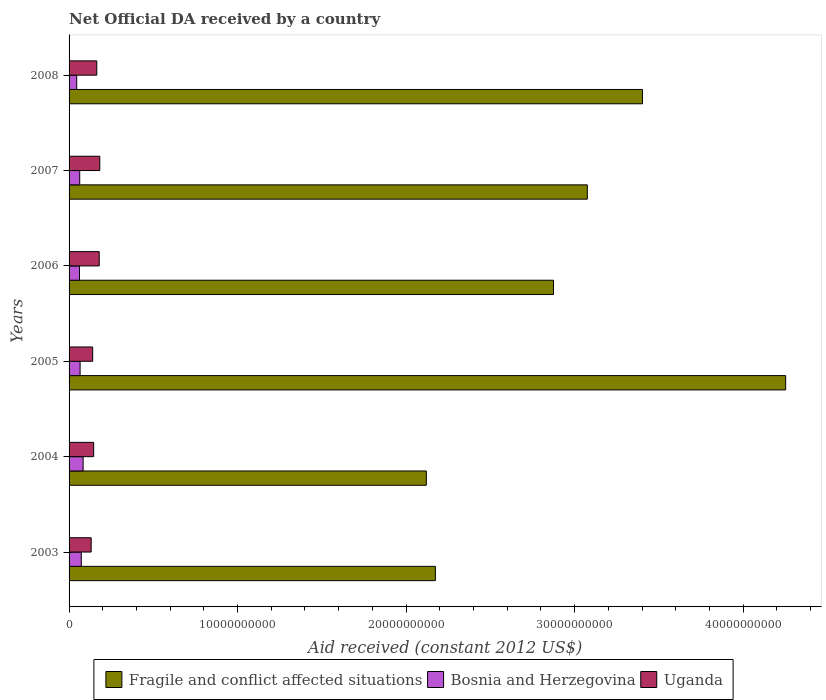How many groups of bars are there?
Offer a very short reply. 6. How many bars are there on the 2nd tick from the top?
Your answer should be compact. 3. How many bars are there on the 1st tick from the bottom?
Ensure brevity in your answer.  3. What is the net official development assistance aid received in Bosnia and Herzegovina in 2003?
Your answer should be very brief. 7.27e+08. Across all years, what is the maximum net official development assistance aid received in Bosnia and Herzegovina?
Your response must be concise. 8.34e+08. Across all years, what is the minimum net official development assistance aid received in Uganda?
Provide a succinct answer. 1.31e+09. In which year was the net official development assistance aid received in Bosnia and Herzegovina maximum?
Your answer should be very brief. 2004. What is the total net official development assistance aid received in Bosnia and Herzegovina in the graph?
Make the answer very short. 3.92e+09. What is the difference between the net official development assistance aid received in Bosnia and Herzegovina in 2003 and that in 2006?
Make the answer very short. 1.08e+08. What is the difference between the net official development assistance aid received in Fragile and conflict affected situations in 2004 and the net official development assistance aid received in Uganda in 2003?
Ensure brevity in your answer.  1.99e+1. What is the average net official development assistance aid received in Fragile and conflict affected situations per year?
Your answer should be very brief. 2.98e+1. In the year 2007, what is the difference between the net official development assistance aid received in Fragile and conflict affected situations and net official development assistance aid received in Bosnia and Herzegovina?
Offer a terse response. 3.01e+1. In how many years, is the net official development assistance aid received in Fragile and conflict affected situations greater than 20000000000 US$?
Ensure brevity in your answer.  6. What is the ratio of the net official development assistance aid received in Bosnia and Herzegovina in 2005 to that in 2008?
Provide a succinct answer. 1.44. Is the difference between the net official development assistance aid received in Fragile and conflict affected situations in 2003 and 2005 greater than the difference between the net official development assistance aid received in Bosnia and Herzegovina in 2003 and 2005?
Your response must be concise. No. What is the difference between the highest and the second highest net official development assistance aid received in Bosnia and Herzegovina?
Provide a succinct answer. 1.07e+08. What is the difference between the highest and the lowest net official development assistance aid received in Uganda?
Offer a terse response. 5.11e+08. What does the 2nd bar from the top in 2007 represents?
Offer a terse response. Bosnia and Herzegovina. What does the 1st bar from the bottom in 2005 represents?
Keep it short and to the point. Fragile and conflict affected situations. Is it the case that in every year, the sum of the net official development assistance aid received in Uganda and net official development assistance aid received in Bosnia and Herzegovina is greater than the net official development assistance aid received in Fragile and conflict affected situations?
Provide a succinct answer. No. Are the values on the major ticks of X-axis written in scientific E-notation?
Give a very brief answer. No. Does the graph contain any zero values?
Give a very brief answer. No. Where does the legend appear in the graph?
Make the answer very short. Bottom center. How are the legend labels stacked?
Offer a very short reply. Horizontal. What is the title of the graph?
Keep it short and to the point. Net Official DA received by a country. What is the label or title of the X-axis?
Keep it short and to the point. Aid received (constant 2012 US$). What is the Aid received (constant 2012 US$) of Fragile and conflict affected situations in 2003?
Ensure brevity in your answer.  2.17e+1. What is the Aid received (constant 2012 US$) in Bosnia and Herzegovina in 2003?
Your answer should be compact. 7.27e+08. What is the Aid received (constant 2012 US$) of Uganda in 2003?
Give a very brief answer. 1.31e+09. What is the Aid received (constant 2012 US$) in Fragile and conflict affected situations in 2004?
Ensure brevity in your answer.  2.12e+1. What is the Aid received (constant 2012 US$) of Bosnia and Herzegovina in 2004?
Ensure brevity in your answer.  8.34e+08. What is the Aid received (constant 2012 US$) of Uganda in 2004?
Offer a terse response. 1.46e+09. What is the Aid received (constant 2012 US$) of Fragile and conflict affected situations in 2005?
Make the answer very short. 4.25e+1. What is the Aid received (constant 2012 US$) in Bosnia and Herzegovina in 2005?
Your answer should be compact. 6.54e+08. What is the Aid received (constant 2012 US$) of Uganda in 2005?
Your answer should be compact. 1.40e+09. What is the Aid received (constant 2012 US$) in Fragile and conflict affected situations in 2006?
Provide a succinct answer. 2.87e+1. What is the Aid received (constant 2012 US$) of Bosnia and Herzegovina in 2006?
Your answer should be very brief. 6.19e+08. What is the Aid received (constant 2012 US$) in Uganda in 2006?
Offer a terse response. 1.79e+09. What is the Aid received (constant 2012 US$) in Fragile and conflict affected situations in 2007?
Your answer should be very brief. 3.08e+1. What is the Aid received (constant 2012 US$) in Bosnia and Herzegovina in 2007?
Your answer should be compact. 6.32e+08. What is the Aid received (constant 2012 US$) of Uganda in 2007?
Keep it short and to the point. 1.82e+09. What is the Aid received (constant 2012 US$) of Fragile and conflict affected situations in 2008?
Ensure brevity in your answer.  3.40e+1. What is the Aid received (constant 2012 US$) in Bosnia and Herzegovina in 2008?
Your response must be concise. 4.54e+08. What is the Aid received (constant 2012 US$) in Uganda in 2008?
Your response must be concise. 1.64e+09. Across all years, what is the maximum Aid received (constant 2012 US$) of Fragile and conflict affected situations?
Give a very brief answer. 4.25e+1. Across all years, what is the maximum Aid received (constant 2012 US$) in Bosnia and Herzegovina?
Keep it short and to the point. 8.34e+08. Across all years, what is the maximum Aid received (constant 2012 US$) in Uganda?
Make the answer very short. 1.82e+09. Across all years, what is the minimum Aid received (constant 2012 US$) in Fragile and conflict affected situations?
Provide a succinct answer. 2.12e+1. Across all years, what is the minimum Aid received (constant 2012 US$) of Bosnia and Herzegovina?
Make the answer very short. 4.54e+08. Across all years, what is the minimum Aid received (constant 2012 US$) of Uganda?
Keep it short and to the point. 1.31e+09. What is the total Aid received (constant 2012 US$) of Fragile and conflict affected situations in the graph?
Offer a very short reply. 1.79e+11. What is the total Aid received (constant 2012 US$) of Bosnia and Herzegovina in the graph?
Your answer should be very brief. 3.92e+09. What is the total Aid received (constant 2012 US$) of Uganda in the graph?
Make the answer very short. 9.43e+09. What is the difference between the Aid received (constant 2012 US$) in Fragile and conflict affected situations in 2003 and that in 2004?
Make the answer very short. 5.38e+08. What is the difference between the Aid received (constant 2012 US$) in Bosnia and Herzegovina in 2003 and that in 2004?
Offer a terse response. -1.07e+08. What is the difference between the Aid received (constant 2012 US$) in Uganda in 2003 and that in 2004?
Your answer should be compact. -1.49e+08. What is the difference between the Aid received (constant 2012 US$) of Fragile and conflict affected situations in 2003 and that in 2005?
Ensure brevity in your answer.  -2.08e+1. What is the difference between the Aid received (constant 2012 US$) of Bosnia and Herzegovina in 2003 and that in 2005?
Offer a very short reply. 7.26e+07. What is the difference between the Aid received (constant 2012 US$) in Uganda in 2003 and that in 2005?
Your response must be concise. -8.92e+07. What is the difference between the Aid received (constant 2012 US$) of Fragile and conflict affected situations in 2003 and that in 2006?
Ensure brevity in your answer.  -7.01e+09. What is the difference between the Aid received (constant 2012 US$) of Bosnia and Herzegovina in 2003 and that in 2006?
Your response must be concise. 1.08e+08. What is the difference between the Aid received (constant 2012 US$) in Uganda in 2003 and that in 2006?
Your answer should be compact. -4.77e+08. What is the difference between the Aid received (constant 2012 US$) of Fragile and conflict affected situations in 2003 and that in 2007?
Offer a very short reply. -9.02e+09. What is the difference between the Aid received (constant 2012 US$) in Bosnia and Herzegovina in 2003 and that in 2007?
Make the answer very short. 9.45e+07. What is the difference between the Aid received (constant 2012 US$) of Uganda in 2003 and that in 2007?
Your answer should be very brief. -5.11e+08. What is the difference between the Aid received (constant 2012 US$) of Fragile and conflict affected situations in 2003 and that in 2008?
Keep it short and to the point. -1.23e+1. What is the difference between the Aid received (constant 2012 US$) of Bosnia and Herzegovina in 2003 and that in 2008?
Keep it short and to the point. 2.73e+08. What is the difference between the Aid received (constant 2012 US$) of Uganda in 2003 and that in 2008?
Provide a succinct answer. -3.33e+08. What is the difference between the Aid received (constant 2012 US$) in Fragile and conflict affected situations in 2004 and that in 2005?
Ensure brevity in your answer.  -2.13e+1. What is the difference between the Aid received (constant 2012 US$) in Bosnia and Herzegovina in 2004 and that in 2005?
Make the answer very short. 1.80e+08. What is the difference between the Aid received (constant 2012 US$) of Uganda in 2004 and that in 2005?
Offer a terse response. 5.95e+07. What is the difference between the Aid received (constant 2012 US$) of Fragile and conflict affected situations in 2004 and that in 2006?
Provide a succinct answer. -7.55e+09. What is the difference between the Aid received (constant 2012 US$) in Bosnia and Herzegovina in 2004 and that in 2006?
Make the answer very short. 2.15e+08. What is the difference between the Aid received (constant 2012 US$) of Uganda in 2004 and that in 2006?
Your answer should be very brief. -3.29e+08. What is the difference between the Aid received (constant 2012 US$) of Fragile and conflict affected situations in 2004 and that in 2007?
Your answer should be compact. -9.55e+09. What is the difference between the Aid received (constant 2012 US$) of Bosnia and Herzegovina in 2004 and that in 2007?
Provide a short and direct response. 2.02e+08. What is the difference between the Aid received (constant 2012 US$) of Uganda in 2004 and that in 2007?
Your response must be concise. -3.62e+08. What is the difference between the Aid received (constant 2012 US$) of Fragile and conflict affected situations in 2004 and that in 2008?
Provide a succinct answer. -1.28e+1. What is the difference between the Aid received (constant 2012 US$) of Bosnia and Herzegovina in 2004 and that in 2008?
Offer a terse response. 3.80e+08. What is the difference between the Aid received (constant 2012 US$) of Uganda in 2004 and that in 2008?
Offer a very short reply. -1.84e+08. What is the difference between the Aid received (constant 2012 US$) of Fragile and conflict affected situations in 2005 and that in 2006?
Your answer should be very brief. 1.38e+1. What is the difference between the Aid received (constant 2012 US$) of Bosnia and Herzegovina in 2005 and that in 2006?
Ensure brevity in your answer.  3.50e+07. What is the difference between the Aid received (constant 2012 US$) in Uganda in 2005 and that in 2006?
Your answer should be very brief. -3.88e+08. What is the difference between the Aid received (constant 2012 US$) of Fragile and conflict affected situations in 2005 and that in 2007?
Offer a terse response. 1.18e+1. What is the difference between the Aid received (constant 2012 US$) in Bosnia and Herzegovina in 2005 and that in 2007?
Provide a succinct answer. 2.19e+07. What is the difference between the Aid received (constant 2012 US$) in Uganda in 2005 and that in 2007?
Your answer should be compact. -4.21e+08. What is the difference between the Aid received (constant 2012 US$) of Fragile and conflict affected situations in 2005 and that in 2008?
Your answer should be very brief. 8.50e+09. What is the difference between the Aid received (constant 2012 US$) in Bosnia and Herzegovina in 2005 and that in 2008?
Keep it short and to the point. 2.00e+08. What is the difference between the Aid received (constant 2012 US$) in Uganda in 2005 and that in 2008?
Offer a very short reply. -2.44e+08. What is the difference between the Aid received (constant 2012 US$) of Fragile and conflict affected situations in 2006 and that in 2007?
Offer a very short reply. -2.01e+09. What is the difference between the Aid received (constant 2012 US$) in Bosnia and Herzegovina in 2006 and that in 2007?
Your response must be concise. -1.30e+07. What is the difference between the Aid received (constant 2012 US$) in Uganda in 2006 and that in 2007?
Your answer should be compact. -3.32e+07. What is the difference between the Aid received (constant 2012 US$) in Fragile and conflict affected situations in 2006 and that in 2008?
Give a very brief answer. -5.28e+09. What is the difference between the Aid received (constant 2012 US$) in Bosnia and Herzegovina in 2006 and that in 2008?
Give a very brief answer. 1.65e+08. What is the difference between the Aid received (constant 2012 US$) in Uganda in 2006 and that in 2008?
Make the answer very short. 1.44e+08. What is the difference between the Aid received (constant 2012 US$) in Fragile and conflict affected situations in 2007 and that in 2008?
Your response must be concise. -3.27e+09. What is the difference between the Aid received (constant 2012 US$) of Bosnia and Herzegovina in 2007 and that in 2008?
Provide a short and direct response. 1.78e+08. What is the difference between the Aid received (constant 2012 US$) in Uganda in 2007 and that in 2008?
Your answer should be compact. 1.78e+08. What is the difference between the Aid received (constant 2012 US$) in Fragile and conflict affected situations in 2003 and the Aid received (constant 2012 US$) in Bosnia and Herzegovina in 2004?
Provide a short and direct response. 2.09e+1. What is the difference between the Aid received (constant 2012 US$) in Fragile and conflict affected situations in 2003 and the Aid received (constant 2012 US$) in Uganda in 2004?
Keep it short and to the point. 2.03e+1. What is the difference between the Aid received (constant 2012 US$) in Bosnia and Herzegovina in 2003 and the Aid received (constant 2012 US$) in Uganda in 2004?
Your response must be concise. -7.33e+08. What is the difference between the Aid received (constant 2012 US$) of Fragile and conflict affected situations in 2003 and the Aid received (constant 2012 US$) of Bosnia and Herzegovina in 2005?
Your response must be concise. 2.11e+1. What is the difference between the Aid received (constant 2012 US$) of Fragile and conflict affected situations in 2003 and the Aid received (constant 2012 US$) of Uganda in 2005?
Make the answer very short. 2.03e+1. What is the difference between the Aid received (constant 2012 US$) of Bosnia and Herzegovina in 2003 and the Aid received (constant 2012 US$) of Uganda in 2005?
Provide a short and direct response. -6.74e+08. What is the difference between the Aid received (constant 2012 US$) in Fragile and conflict affected situations in 2003 and the Aid received (constant 2012 US$) in Bosnia and Herzegovina in 2006?
Your answer should be compact. 2.11e+1. What is the difference between the Aid received (constant 2012 US$) in Fragile and conflict affected situations in 2003 and the Aid received (constant 2012 US$) in Uganda in 2006?
Keep it short and to the point. 1.99e+1. What is the difference between the Aid received (constant 2012 US$) in Bosnia and Herzegovina in 2003 and the Aid received (constant 2012 US$) in Uganda in 2006?
Your response must be concise. -1.06e+09. What is the difference between the Aid received (constant 2012 US$) of Fragile and conflict affected situations in 2003 and the Aid received (constant 2012 US$) of Bosnia and Herzegovina in 2007?
Make the answer very short. 2.11e+1. What is the difference between the Aid received (constant 2012 US$) of Fragile and conflict affected situations in 2003 and the Aid received (constant 2012 US$) of Uganda in 2007?
Provide a short and direct response. 1.99e+1. What is the difference between the Aid received (constant 2012 US$) of Bosnia and Herzegovina in 2003 and the Aid received (constant 2012 US$) of Uganda in 2007?
Provide a succinct answer. -1.10e+09. What is the difference between the Aid received (constant 2012 US$) in Fragile and conflict affected situations in 2003 and the Aid received (constant 2012 US$) in Bosnia and Herzegovina in 2008?
Your response must be concise. 2.13e+1. What is the difference between the Aid received (constant 2012 US$) of Fragile and conflict affected situations in 2003 and the Aid received (constant 2012 US$) of Uganda in 2008?
Your answer should be compact. 2.01e+1. What is the difference between the Aid received (constant 2012 US$) of Bosnia and Herzegovina in 2003 and the Aid received (constant 2012 US$) of Uganda in 2008?
Make the answer very short. -9.18e+08. What is the difference between the Aid received (constant 2012 US$) of Fragile and conflict affected situations in 2004 and the Aid received (constant 2012 US$) of Bosnia and Herzegovina in 2005?
Make the answer very short. 2.05e+1. What is the difference between the Aid received (constant 2012 US$) of Fragile and conflict affected situations in 2004 and the Aid received (constant 2012 US$) of Uganda in 2005?
Your answer should be very brief. 1.98e+1. What is the difference between the Aid received (constant 2012 US$) of Bosnia and Herzegovina in 2004 and the Aid received (constant 2012 US$) of Uganda in 2005?
Provide a short and direct response. -5.66e+08. What is the difference between the Aid received (constant 2012 US$) of Fragile and conflict affected situations in 2004 and the Aid received (constant 2012 US$) of Bosnia and Herzegovina in 2006?
Make the answer very short. 2.06e+1. What is the difference between the Aid received (constant 2012 US$) of Fragile and conflict affected situations in 2004 and the Aid received (constant 2012 US$) of Uganda in 2006?
Your answer should be compact. 1.94e+1. What is the difference between the Aid received (constant 2012 US$) of Bosnia and Herzegovina in 2004 and the Aid received (constant 2012 US$) of Uganda in 2006?
Offer a terse response. -9.55e+08. What is the difference between the Aid received (constant 2012 US$) in Fragile and conflict affected situations in 2004 and the Aid received (constant 2012 US$) in Bosnia and Herzegovina in 2007?
Offer a terse response. 2.06e+1. What is the difference between the Aid received (constant 2012 US$) in Fragile and conflict affected situations in 2004 and the Aid received (constant 2012 US$) in Uganda in 2007?
Give a very brief answer. 1.94e+1. What is the difference between the Aid received (constant 2012 US$) in Bosnia and Herzegovina in 2004 and the Aid received (constant 2012 US$) in Uganda in 2007?
Ensure brevity in your answer.  -9.88e+08. What is the difference between the Aid received (constant 2012 US$) in Fragile and conflict affected situations in 2004 and the Aid received (constant 2012 US$) in Bosnia and Herzegovina in 2008?
Give a very brief answer. 2.07e+1. What is the difference between the Aid received (constant 2012 US$) of Fragile and conflict affected situations in 2004 and the Aid received (constant 2012 US$) of Uganda in 2008?
Provide a short and direct response. 1.96e+1. What is the difference between the Aid received (constant 2012 US$) of Bosnia and Herzegovina in 2004 and the Aid received (constant 2012 US$) of Uganda in 2008?
Provide a short and direct response. -8.10e+08. What is the difference between the Aid received (constant 2012 US$) of Fragile and conflict affected situations in 2005 and the Aid received (constant 2012 US$) of Bosnia and Herzegovina in 2006?
Provide a short and direct response. 4.19e+1. What is the difference between the Aid received (constant 2012 US$) in Fragile and conflict affected situations in 2005 and the Aid received (constant 2012 US$) in Uganda in 2006?
Offer a very short reply. 4.07e+1. What is the difference between the Aid received (constant 2012 US$) of Bosnia and Herzegovina in 2005 and the Aid received (constant 2012 US$) of Uganda in 2006?
Offer a terse response. -1.13e+09. What is the difference between the Aid received (constant 2012 US$) of Fragile and conflict affected situations in 2005 and the Aid received (constant 2012 US$) of Bosnia and Herzegovina in 2007?
Offer a very short reply. 4.19e+1. What is the difference between the Aid received (constant 2012 US$) in Fragile and conflict affected situations in 2005 and the Aid received (constant 2012 US$) in Uganda in 2007?
Your response must be concise. 4.07e+1. What is the difference between the Aid received (constant 2012 US$) in Bosnia and Herzegovina in 2005 and the Aid received (constant 2012 US$) in Uganda in 2007?
Give a very brief answer. -1.17e+09. What is the difference between the Aid received (constant 2012 US$) of Fragile and conflict affected situations in 2005 and the Aid received (constant 2012 US$) of Bosnia and Herzegovina in 2008?
Your response must be concise. 4.21e+1. What is the difference between the Aid received (constant 2012 US$) in Fragile and conflict affected situations in 2005 and the Aid received (constant 2012 US$) in Uganda in 2008?
Keep it short and to the point. 4.09e+1. What is the difference between the Aid received (constant 2012 US$) of Bosnia and Herzegovina in 2005 and the Aid received (constant 2012 US$) of Uganda in 2008?
Give a very brief answer. -9.90e+08. What is the difference between the Aid received (constant 2012 US$) of Fragile and conflict affected situations in 2006 and the Aid received (constant 2012 US$) of Bosnia and Herzegovina in 2007?
Your response must be concise. 2.81e+1. What is the difference between the Aid received (constant 2012 US$) of Fragile and conflict affected situations in 2006 and the Aid received (constant 2012 US$) of Uganda in 2007?
Ensure brevity in your answer.  2.69e+1. What is the difference between the Aid received (constant 2012 US$) of Bosnia and Herzegovina in 2006 and the Aid received (constant 2012 US$) of Uganda in 2007?
Your answer should be very brief. -1.20e+09. What is the difference between the Aid received (constant 2012 US$) of Fragile and conflict affected situations in 2006 and the Aid received (constant 2012 US$) of Bosnia and Herzegovina in 2008?
Your response must be concise. 2.83e+1. What is the difference between the Aid received (constant 2012 US$) in Fragile and conflict affected situations in 2006 and the Aid received (constant 2012 US$) in Uganda in 2008?
Offer a very short reply. 2.71e+1. What is the difference between the Aid received (constant 2012 US$) of Bosnia and Herzegovina in 2006 and the Aid received (constant 2012 US$) of Uganda in 2008?
Your answer should be very brief. -1.03e+09. What is the difference between the Aid received (constant 2012 US$) of Fragile and conflict affected situations in 2007 and the Aid received (constant 2012 US$) of Bosnia and Herzegovina in 2008?
Make the answer very short. 3.03e+1. What is the difference between the Aid received (constant 2012 US$) in Fragile and conflict affected situations in 2007 and the Aid received (constant 2012 US$) in Uganda in 2008?
Your response must be concise. 2.91e+1. What is the difference between the Aid received (constant 2012 US$) in Bosnia and Herzegovina in 2007 and the Aid received (constant 2012 US$) in Uganda in 2008?
Your response must be concise. -1.01e+09. What is the average Aid received (constant 2012 US$) in Fragile and conflict affected situations per year?
Your response must be concise. 2.98e+1. What is the average Aid received (constant 2012 US$) in Bosnia and Herzegovina per year?
Ensure brevity in your answer.  6.53e+08. What is the average Aid received (constant 2012 US$) of Uganda per year?
Provide a succinct answer. 1.57e+09. In the year 2003, what is the difference between the Aid received (constant 2012 US$) of Fragile and conflict affected situations and Aid received (constant 2012 US$) of Bosnia and Herzegovina?
Offer a very short reply. 2.10e+1. In the year 2003, what is the difference between the Aid received (constant 2012 US$) in Fragile and conflict affected situations and Aid received (constant 2012 US$) in Uganda?
Your answer should be very brief. 2.04e+1. In the year 2003, what is the difference between the Aid received (constant 2012 US$) in Bosnia and Herzegovina and Aid received (constant 2012 US$) in Uganda?
Ensure brevity in your answer.  -5.85e+08. In the year 2004, what is the difference between the Aid received (constant 2012 US$) of Fragile and conflict affected situations and Aid received (constant 2012 US$) of Bosnia and Herzegovina?
Ensure brevity in your answer.  2.04e+1. In the year 2004, what is the difference between the Aid received (constant 2012 US$) of Fragile and conflict affected situations and Aid received (constant 2012 US$) of Uganda?
Offer a very short reply. 1.97e+1. In the year 2004, what is the difference between the Aid received (constant 2012 US$) of Bosnia and Herzegovina and Aid received (constant 2012 US$) of Uganda?
Offer a very short reply. -6.26e+08. In the year 2005, what is the difference between the Aid received (constant 2012 US$) of Fragile and conflict affected situations and Aid received (constant 2012 US$) of Bosnia and Herzegovina?
Provide a succinct answer. 4.19e+1. In the year 2005, what is the difference between the Aid received (constant 2012 US$) of Fragile and conflict affected situations and Aid received (constant 2012 US$) of Uganda?
Your response must be concise. 4.11e+1. In the year 2005, what is the difference between the Aid received (constant 2012 US$) in Bosnia and Herzegovina and Aid received (constant 2012 US$) in Uganda?
Your answer should be very brief. -7.46e+08. In the year 2006, what is the difference between the Aid received (constant 2012 US$) of Fragile and conflict affected situations and Aid received (constant 2012 US$) of Bosnia and Herzegovina?
Offer a terse response. 2.81e+1. In the year 2006, what is the difference between the Aid received (constant 2012 US$) in Fragile and conflict affected situations and Aid received (constant 2012 US$) in Uganda?
Your response must be concise. 2.70e+1. In the year 2006, what is the difference between the Aid received (constant 2012 US$) of Bosnia and Herzegovina and Aid received (constant 2012 US$) of Uganda?
Offer a terse response. -1.17e+09. In the year 2007, what is the difference between the Aid received (constant 2012 US$) in Fragile and conflict affected situations and Aid received (constant 2012 US$) in Bosnia and Herzegovina?
Ensure brevity in your answer.  3.01e+1. In the year 2007, what is the difference between the Aid received (constant 2012 US$) in Fragile and conflict affected situations and Aid received (constant 2012 US$) in Uganda?
Your answer should be very brief. 2.89e+1. In the year 2007, what is the difference between the Aid received (constant 2012 US$) of Bosnia and Herzegovina and Aid received (constant 2012 US$) of Uganda?
Make the answer very short. -1.19e+09. In the year 2008, what is the difference between the Aid received (constant 2012 US$) of Fragile and conflict affected situations and Aid received (constant 2012 US$) of Bosnia and Herzegovina?
Your answer should be very brief. 3.36e+1. In the year 2008, what is the difference between the Aid received (constant 2012 US$) of Fragile and conflict affected situations and Aid received (constant 2012 US$) of Uganda?
Your answer should be compact. 3.24e+1. In the year 2008, what is the difference between the Aid received (constant 2012 US$) of Bosnia and Herzegovina and Aid received (constant 2012 US$) of Uganda?
Keep it short and to the point. -1.19e+09. What is the ratio of the Aid received (constant 2012 US$) in Fragile and conflict affected situations in 2003 to that in 2004?
Provide a succinct answer. 1.03. What is the ratio of the Aid received (constant 2012 US$) in Bosnia and Herzegovina in 2003 to that in 2004?
Ensure brevity in your answer.  0.87. What is the ratio of the Aid received (constant 2012 US$) in Uganda in 2003 to that in 2004?
Keep it short and to the point. 0.9. What is the ratio of the Aid received (constant 2012 US$) in Fragile and conflict affected situations in 2003 to that in 2005?
Give a very brief answer. 0.51. What is the ratio of the Aid received (constant 2012 US$) of Bosnia and Herzegovina in 2003 to that in 2005?
Ensure brevity in your answer.  1.11. What is the ratio of the Aid received (constant 2012 US$) of Uganda in 2003 to that in 2005?
Ensure brevity in your answer.  0.94. What is the ratio of the Aid received (constant 2012 US$) in Fragile and conflict affected situations in 2003 to that in 2006?
Provide a succinct answer. 0.76. What is the ratio of the Aid received (constant 2012 US$) of Bosnia and Herzegovina in 2003 to that in 2006?
Offer a terse response. 1.17. What is the ratio of the Aid received (constant 2012 US$) of Uganda in 2003 to that in 2006?
Ensure brevity in your answer.  0.73. What is the ratio of the Aid received (constant 2012 US$) in Fragile and conflict affected situations in 2003 to that in 2007?
Keep it short and to the point. 0.71. What is the ratio of the Aid received (constant 2012 US$) of Bosnia and Herzegovina in 2003 to that in 2007?
Keep it short and to the point. 1.15. What is the ratio of the Aid received (constant 2012 US$) of Uganda in 2003 to that in 2007?
Make the answer very short. 0.72. What is the ratio of the Aid received (constant 2012 US$) of Fragile and conflict affected situations in 2003 to that in 2008?
Your answer should be compact. 0.64. What is the ratio of the Aid received (constant 2012 US$) in Uganda in 2003 to that in 2008?
Your answer should be very brief. 0.8. What is the ratio of the Aid received (constant 2012 US$) in Fragile and conflict affected situations in 2004 to that in 2005?
Provide a succinct answer. 0.5. What is the ratio of the Aid received (constant 2012 US$) of Bosnia and Herzegovina in 2004 to that in 2005?
Ensure brevity in your answer.  1.28. What is the ratio of the Aid received (constant 2012 US$) of Uganda in 2004 to that in 2005?
Your answer should be very brief. 1.04. What is the ratio of the Aid received (constant 2012 US$) in Fragile and conflict affected situations in 2004 to that in 2006?
Your response must be concise. 0.74. What is the ratio of the Aid received (constant 2012 US$) of Bosnia and Herzegovina in 2004 to that in 2006?
Provide a succinct answer. 1.35. What is the ratio of the Aid received (constant 2012 US$) of Uganda in 2004 to that in 2006?
Provide a short and direct response. 0.82. What is the ratio of the Aid received (constant 2012 US$) of Fragile and conflict affected situations in 2004 to that in 2007?
Offer a very short reply. 0.69. What is the ratio of the Aid received (constant 2012 US$) of Bosnia and Herzegovina in 2004 to that in 2007?
Your response must be concise. 1.32. What is the ratio of the Aid received (constant 2012 US$) in Uganda in 2004 to that in 2007?
Keep it short and to the point. 0.8. What is the ratio of the Aid received (constant 2012 US$) in Fragile and conflict affected situations in 2004 to that in 2008?
Ensure brevity in your answer.  0.62. What is the ratio of the Aid received (constant 2012 US$) in Bosnia and Herzegovina in 2004 to that in 2008?
Make the answer very short. 1.84. What is the ratio of the Aid received (constant 2012 US$) of Uganda in 2004 to that in 2008?
Provide a succinct answer. 0.89. What is the ratio of the Aid received (constant 2012 US$) of Fragile and conflict affected situations in 2005 to that in 2006?
Ensure brevity in your answer.  1.48. What is the ratio of the Aid received (constant 2012 US$) of Bosnia and Herzegovina in 2005 to that in 2006?
Offer a terse response. 1.06. What is the ratio of the Aid received (constant 2012 US$) of Uganda in 2005 to that in 2006?
Keep it short and to the point. 0.78. What is the ratio of the Aid received (constant 2012 US$) of Fragile and conflict affected situations in 2005 to that in 2007?
Keep it short and to the point. 1.38. What is the ratio of the Aid received (constant 2012 US$) in Bosnia and Herzegovina in 2005 to that in 2007?
Your answer should be compact. 1.03. What is the ratio of the Aid received (constant 2012 US$) in Uganda in 2005 to that in 2007?
Offer a very short reply. 0.77. What is the ratio of the Aid received (constant 2012 US$) in Fragile and conflict affected situations in 2005 to that in 2008?
Give a very brief answer. 1.25. What is the ratio of the Aid received (constant 2012 US$) of Bosnia and Herzegovina in 2005 to that in 2008?
Make the answer very short. 1.44. What is the ratio of the Aid received (constant 2012 US$) in Uganda in 2005 to that in 2008?
Offer a very short reply. 0.85. What is the ratio of the Aid received (constant 2012 US$) of Fragile and conflict affected situations in 2006 to that in 2007?
Keep it short and to the point. 0.93. What is the ratio of the Aid received (constant 2012 US$) in Bosnia and Herzegovina in 2006 to that in 2007?
Ensure brevity in your answer.  0.98. What is the ratio of the Aid received (constant 2012 US$) of Uganda in 2006 to that in 2007?
Keep it short and to the point. 0.98. What is the ratio of the Aid received (constant 2012 US$) in Fragile and conflict affected situations in 2006 to that in 2008?
Ensure brevity in your answer.  0.84. What is the ratio of the Aid received (constant 2012 US$) in Bosnia and Herzegovina in 2006 to that in 2008?
Ensure brevity in your answer.  1.36. What is the ratio of the Aid received (constant 2012 US$) of Uganda in 2006 to that in 2008?
Make the answer very short. 1.09. What is the ratio of the Aid received (constant 2012 US$) in Fragile and conflict affected situations in 2007 to that in 2008?
Provide a succinct answer. 0.9. What is the ratio of the Aid received (constant 2012 US$) of Bosnia and Herzegovina in 2007 to that in 2008?
Your response must be concise. 1.39. What is the ratio of the Aid received (constant 2012 US$) in Uganda in 2007 to that in 2008?
Ensure brevity in your answer.  1.11. What is the difference between the highest and the second highest Aid received (constant 2012 US$) of Fragile and conflict affected situations?
Offer a terse response. 8.50e+09. What is the difference between the highest and the second highest Aid received (constant 2012 US$) of Bosnia and Herzegovina?
Your answer should be very brief. 1.07e+08. What is the difference between the highest and the second highest Aid received (constant 2012 US$) in Uganda?
Give a very brief answer. 3.32e+07. What is the difference between the highest and the lowest Aid received (constant 2012 US$) in Fragile and conflict affected situations?
Provide a succinct answer. 2.13e+1. What is the difference between the highest and the lowest Aid received (constant 2012 US$) of Bosnia and Herzegovina?
Offer a very short reply. 3.80e+08. What is the difference between the highest and the lowest Aid received (constant 2012 US$) in Uganda?
Ensure brevity in your answer.  5.11e+08. 